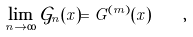Convert formula to latex. <formula><loc_0><loc_0><loc_500><loc_500>\lim _ { n \to \infty } \mathcal { G } _ { n } ( x ) = G ^ { ( m ) } ( x ) \quad ,</formula> 